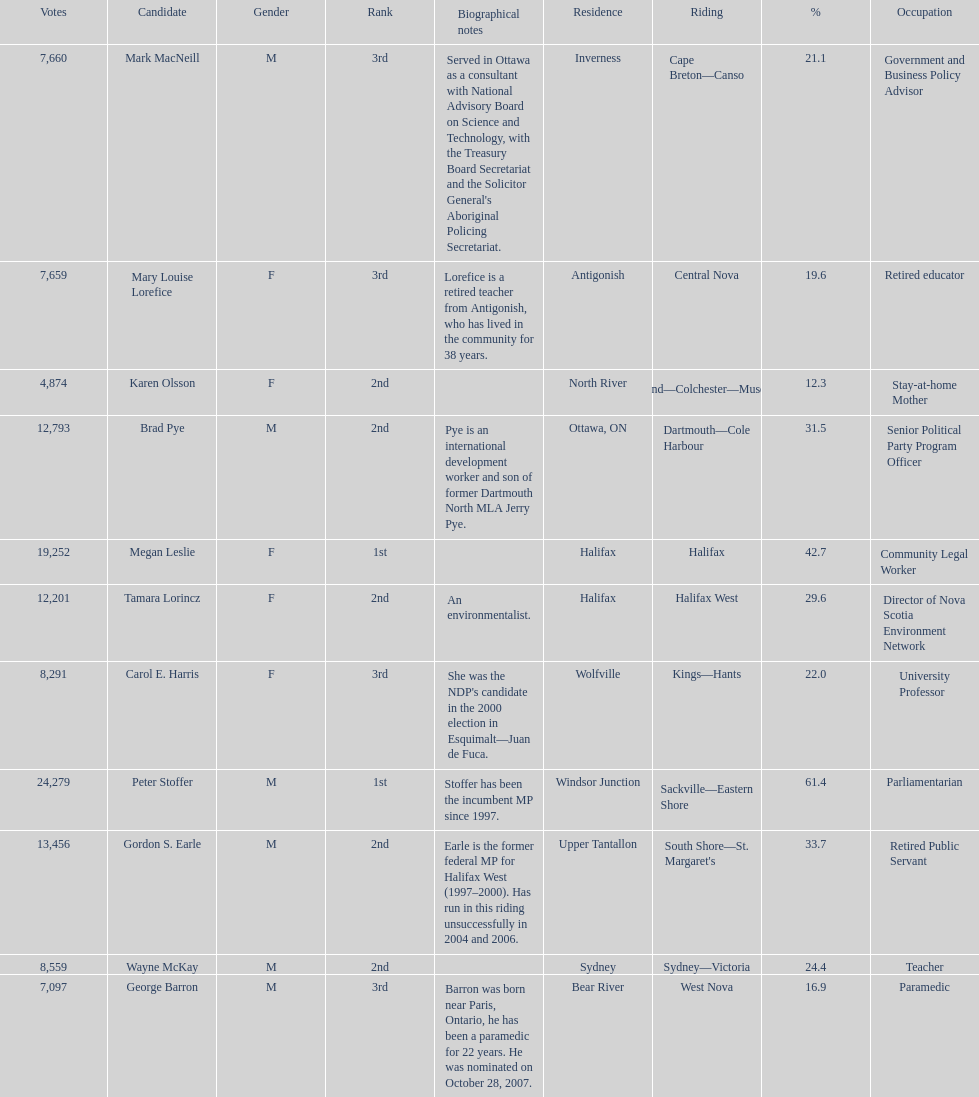What is the total number of candidates? 11. 